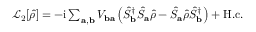Convert formula to latex. <formula><loc_0><loc_0><loc_500><loc_500>\begin{array} { r } { \mathcal { L } _ { 2 } [ \hat { \rho } ] = - i \sum _ { a , b } V _ { b a } \left ( \hat { S } _ { b } ^ { \dagger } \hat { S } _ { a } \hat { \rho } - \hat { S } _ { a } \hat { \rho } \hat { S } _ { b } ^ { \dagger } \right ) + H . c . } \end{array}</formula> 